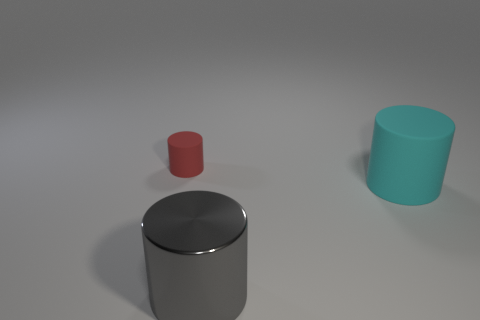Subtract all small rubber cylinders. How many cylinders are left? 2 Add 3 big cyan cylinders. How many objects exist? 6 Subtract 2 cylinders. How many cylinders are left? 1 Subtract all cyan cylinders. How many cylinders are left? 2 Subtract all green cylinders. Subtract all blue blocks. How many cylinders are left? 3 Subtract all large cylinders. Subtract all brown matte balls. How many objects are left? 1 Add 3 big gray metal cylinders. How many big gray metal cylinders are left? 4 Add 3 tiny red metal spheres. How many tiny red metal spheres exist? 3 Subtract 1 gray cylinders. How many objects are left? 2 